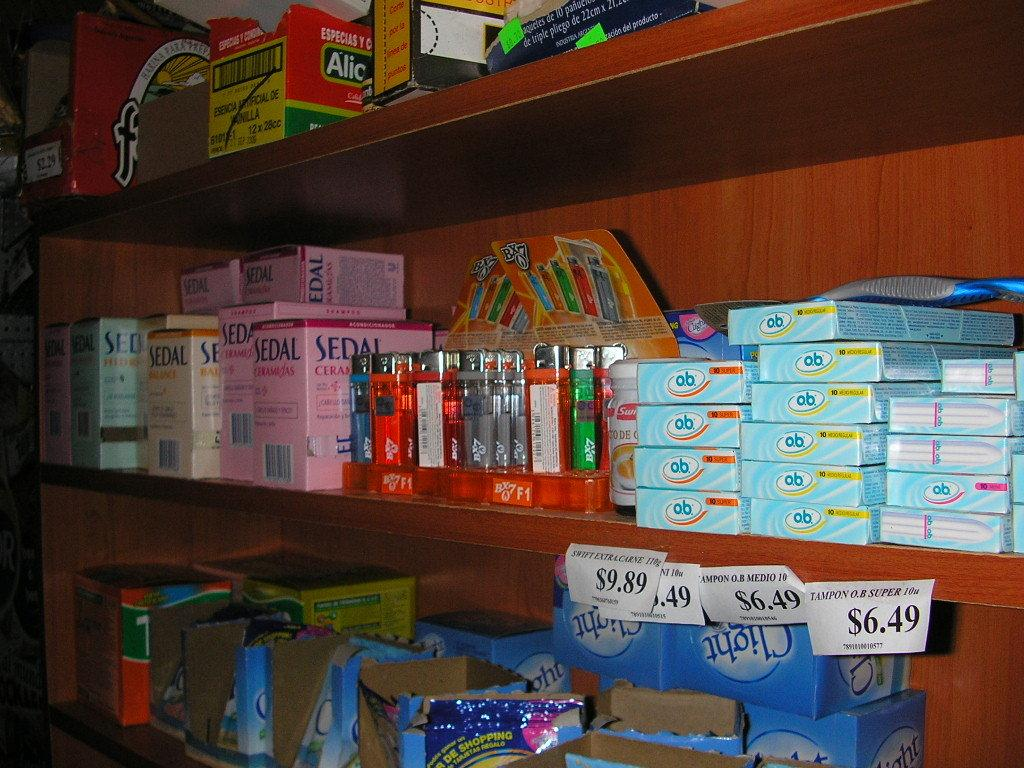<image>
Offer a succinct explanation of the picture presented. Boxes of Sedal in various colors sit on a store shelf. 